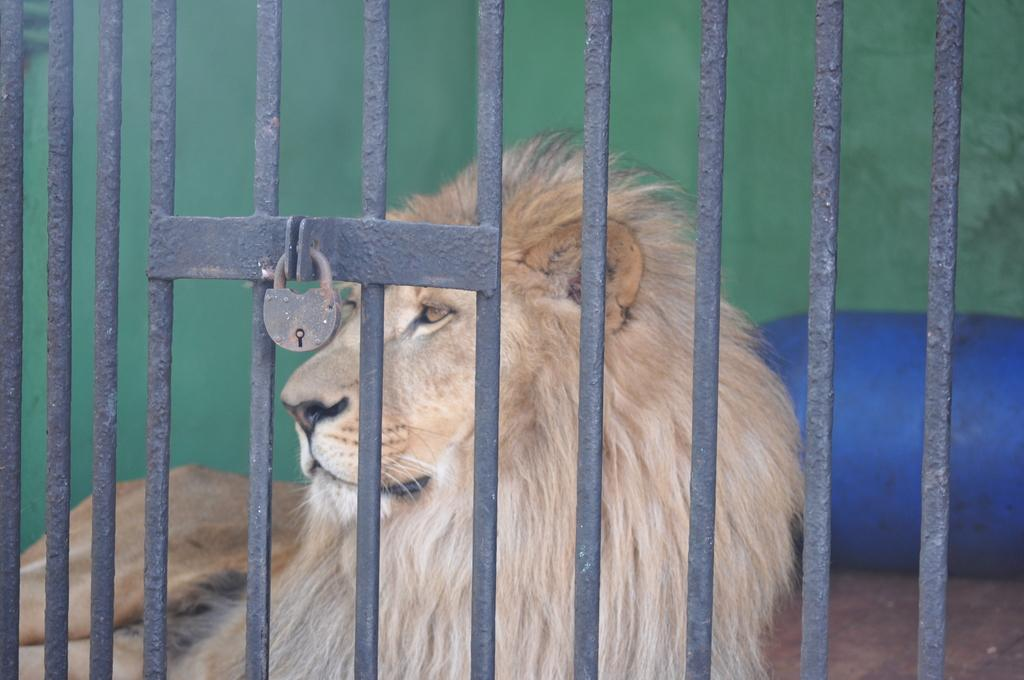What animal is present in the image? There is a lion in the image. Where is the lion located? The lion is in a cage. Is the cage secure? Yes, the cage is locked. What can be seen behind the lion? There is a blue color stone visible behind the lion. What type of mask is the lion wearing in the image? There is no mask present on the lion in the image. What color is the gate near the lion's cage? There is no gate visible in the image; only the cage is present. 